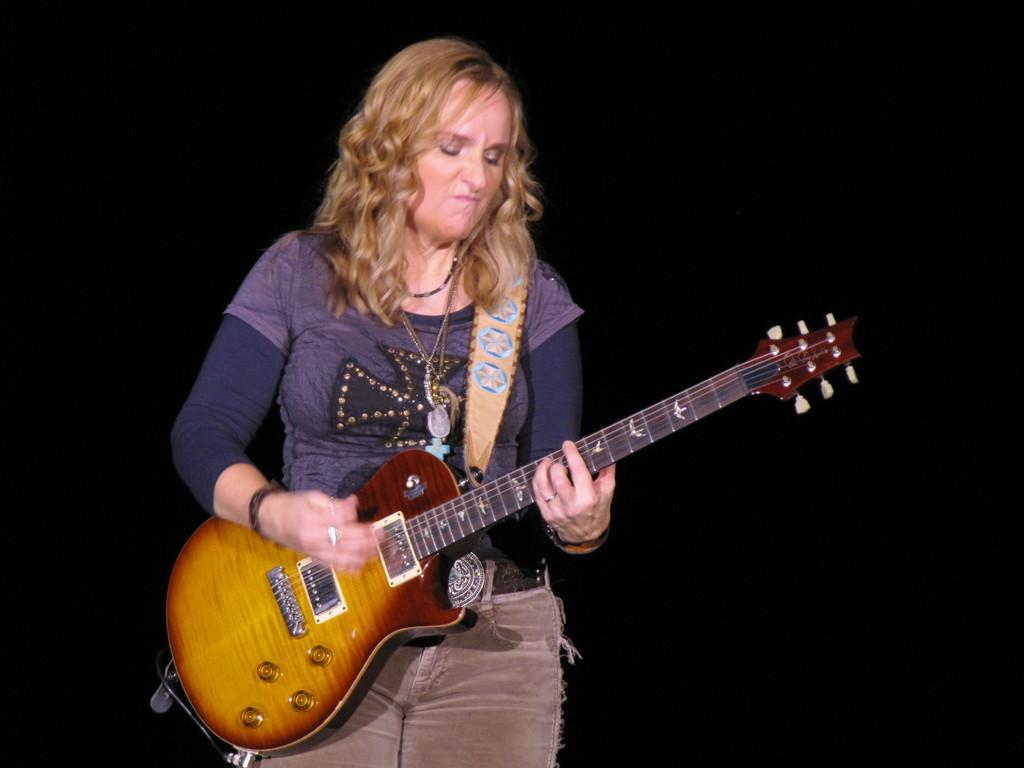Who is the main subject in the image? There is a woman in the image. Can you describe the woman's appearance? The woman has short hair. What is the woman holding in the image? The woman is holding a guitar. What is the woman doing with the guitar? The woman is playing the guitar. What type of crib can be seen in the background of the image? There is no crib present in the image. How many quarters can be seen on the guitar in the image? There are no quarters visible on the guitar in the image. 